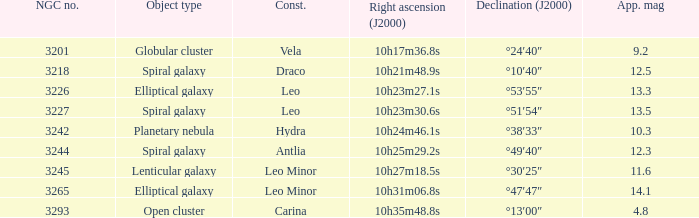What is the sum of NGC numbers for Constellation vela? 3201.0. 